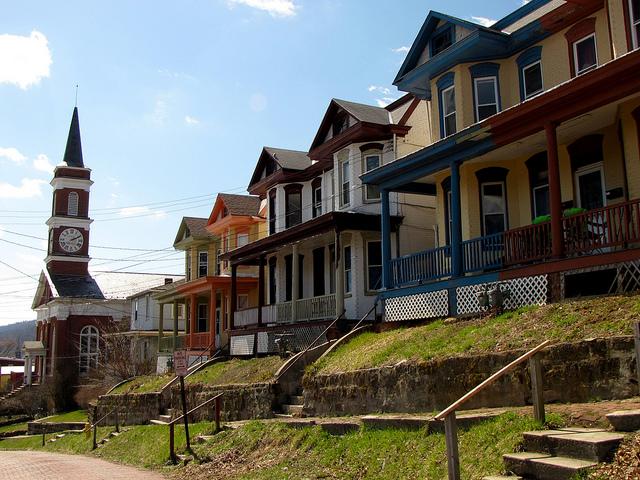Are the houses on ground level?
Short answer required. No. What time does the clock have?
Write a very short answer. 2:10. How many clocks are on the building?
Short answer required. 1. 